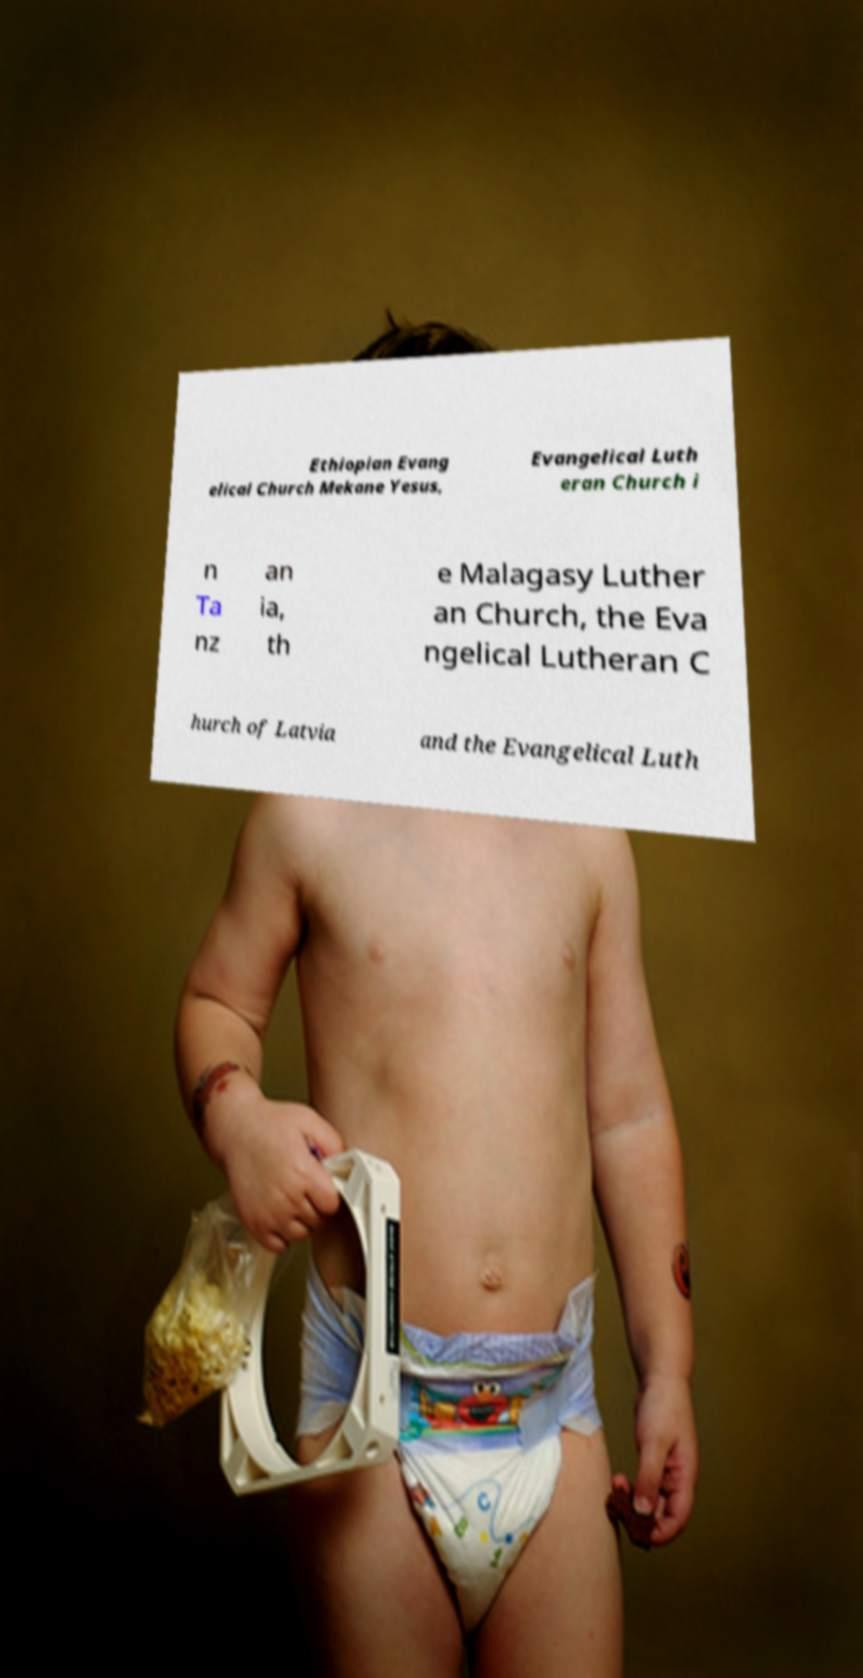There's text embedded in this image that I need extracted. Can you transcribe it verbatim? Ethiopian Evang elical Church Mekane Yesus, Evangelical Luth eran Church i n Ta nz an ia, th e Malagasy Luther an Church, the Eva ngelical Lutheran C hurch of Latvia and the Evangelical Luth 